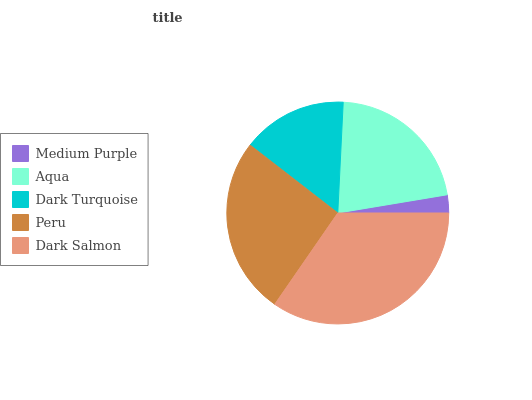Is Medium Purple the minimum?
Answer yes or no. Yes. Is Dark Salmon the maximum?
Answer yes or no. Yes. Is Aqua the minimum?
Answer yes or no. No. Is Aqua the maximum?
Answer yes or no. No. Is Aqua greater than Medium Purple?
Answer yes or no. Yes. Is Medium Purple less than Aqua?
Answer yes or no. Yes. Is Medium Purple greater than Aqua?
Answer yes or no. No. Is Aqua less than Medium Purple?
Answer yes or no. No. Is Aqua the high median?
Answer yes or no. Yes. Is Aqua the low median?
Answer yes or no. Yes. Is Dark Turquoise the high median?
Answer yes or no. No. Is Peru the low median?
Answer yes or no. No. 